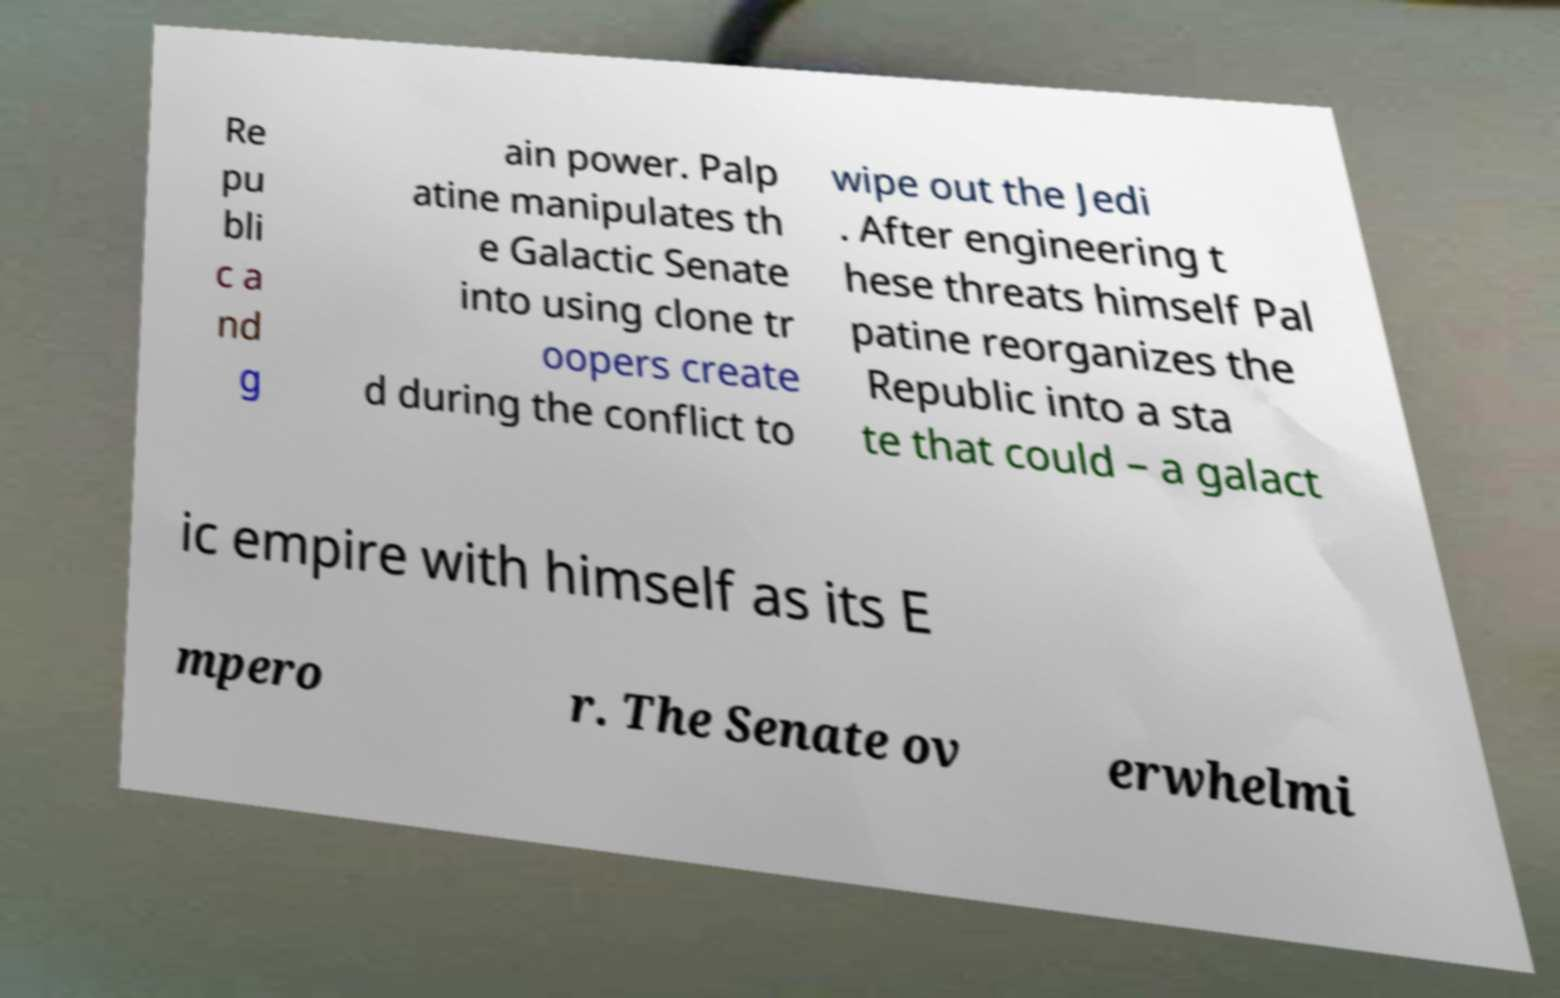Could you extract and type out the text from this image? Re pu bli c a nd g ain power. Palp atine manipulates th e Galactic Senate into using clone tr oopers create d during the conflict to wipe out the Jedi . After engineering t hese threats himself Pal patine reorganizes the Republic into a sta te that could – a galact ic empire with himself as its E mpero r. The Senate ov erwhelmi 